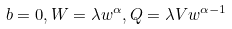<formula> <loc_0><loc_0><loc_500><loc_500>b = 0 , W = \lambda w ^ { \alpha } , Q = \lambda V w ^ { \alpha - 1 }</formula> 